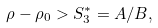Convert formula to latex. <formula><loc_0><loc_0><loc_500><loc_500>\rho - \rho _ { 0 } > S _ { 3 } ^ { * } = A / B ,</formula> 